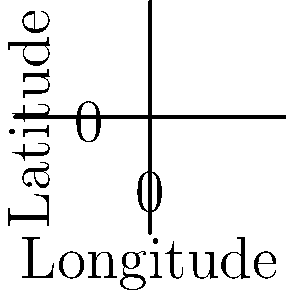Analyze the temperature anomaly map for Mesoamerica. Which temperature anomaly range is most prevalent in the central region, and what does this suggest about future climate scenarios for the area? To interpret the temperature anomaly map for Mesoamerica and determine the most prevalent range in the central region, we need to follow these steps:

1. Identify the central region of Mesoamerica on the map (roughly around coordinates (0,0)).

2. Observe the color patterns in this area and match them to the temperature anomaly scale provided.

3. The central region appears to be predominantly yellow to light green.

4. Referring to the temperature anomaly scale:
   - Yellow corresponds to approximately 0°C anomaly
   - Light green corresponds to approximately 1°C anomaly

5. This suggests that the most prevalent temperature anomaly range in the central region is between 0°C and 1°C.

6. Interpreting this for future climate scenarios:
   - A positive temperature anomaly indicates warmer than average temperatures.
   - The range of 0°C to 1°C suggests a mild warming trend.
   - This mild warming could lead to:
     a. Slight shifts in precipitation patterns
     b. Potential changes in vegetation distribution
     c. Possible impacts on agricultural practices

7. However, it's important to note that this is a simplified model, and actual climate projections would require more complex data and analysis.

In conclusion, the most prevalent temperature anomaly range in the central region of Mesoamerica is 0°C to 1°C, suggesting a mild warming trend in future climate scenarios.
Answer: 0°C to 1°C, indicating mild warming 